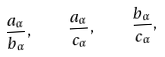Convert formula to latex. <formula><loc_0><loc_0><loc_500><loc_500>\frac { a _ { \alpha } } { b _ { \alpha } } , \quad \frac { a _ { \alpha } } { c _ { \alpha } } , \quad \frac { b _ { \alpha } } { c _ { \alpha } } ,</formula> 